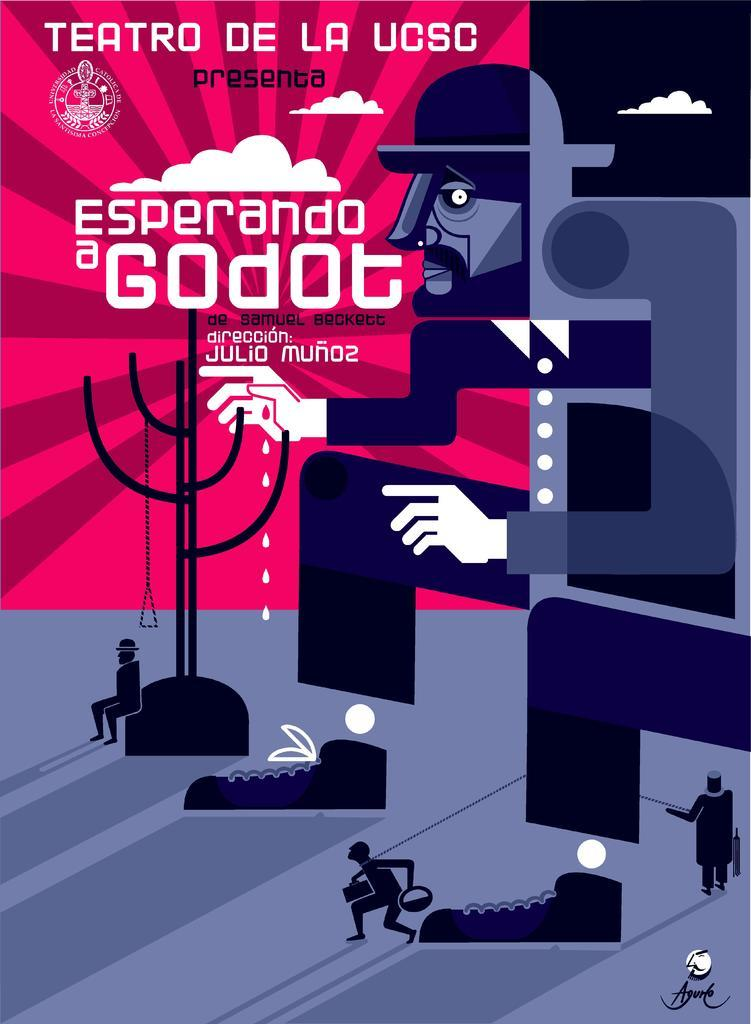What is present in the picture? There is a poster in the picture. What can be found on the poster? The poster contains text. What type of images are in the picture? There are animated pictures in the image. What is the argument about in the image? There is no argument present in the image; it features a poster with text and animated pictures. 